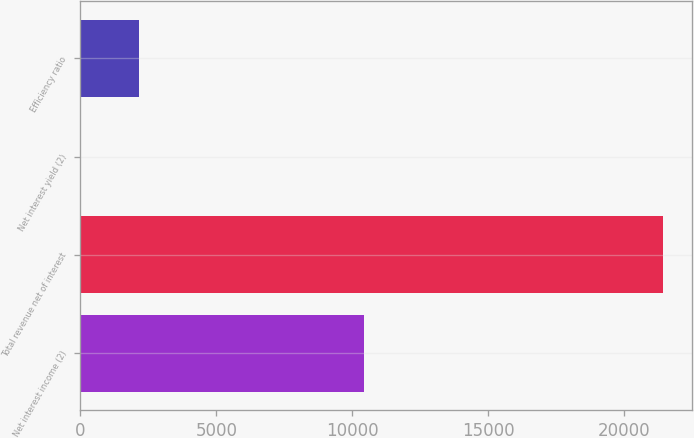Convert chart. <chart><loc_0><loc_0><loc_500><loc_500><bar_chart><fcel>Net interest income (2)<fcel>Total revenue net of interest<fcel>Net interest yield (2)<fcel>Efficiency ratio<nl><fcel>10444<fcel>21434<fcel>2.29<fcel>2145.46<nl></chart> 